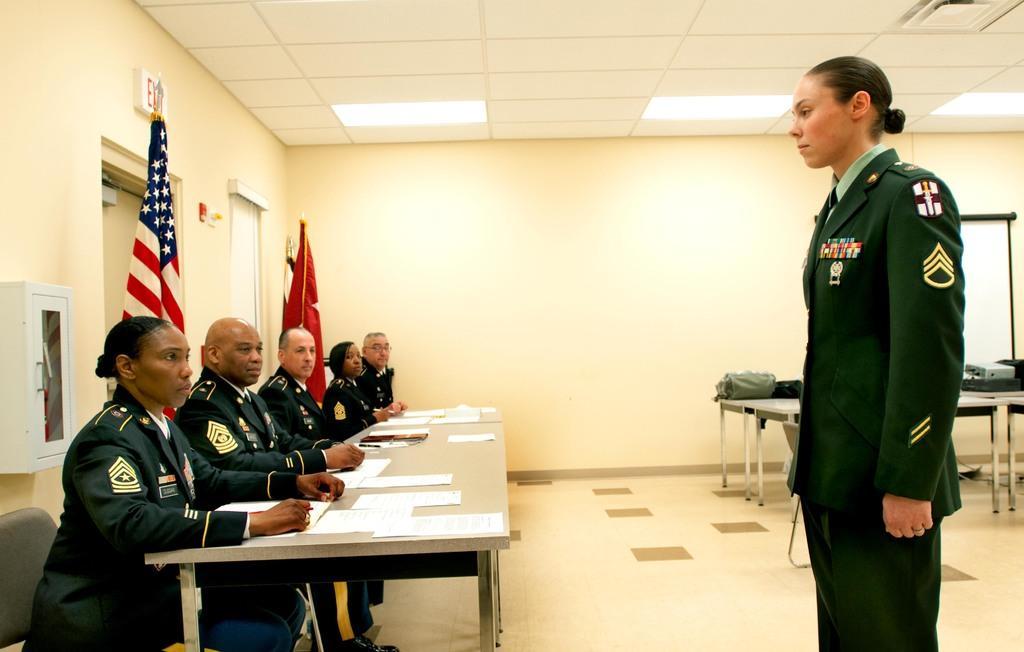Please provide a concise description of this image. In this image we can see a woman standing. On the left we can see the people sitting on the chairs in front of the table. We can also see the flags, doors, exit board, tables and also some other objects. We can also see the board, wall and also the ceiling with the lights. 